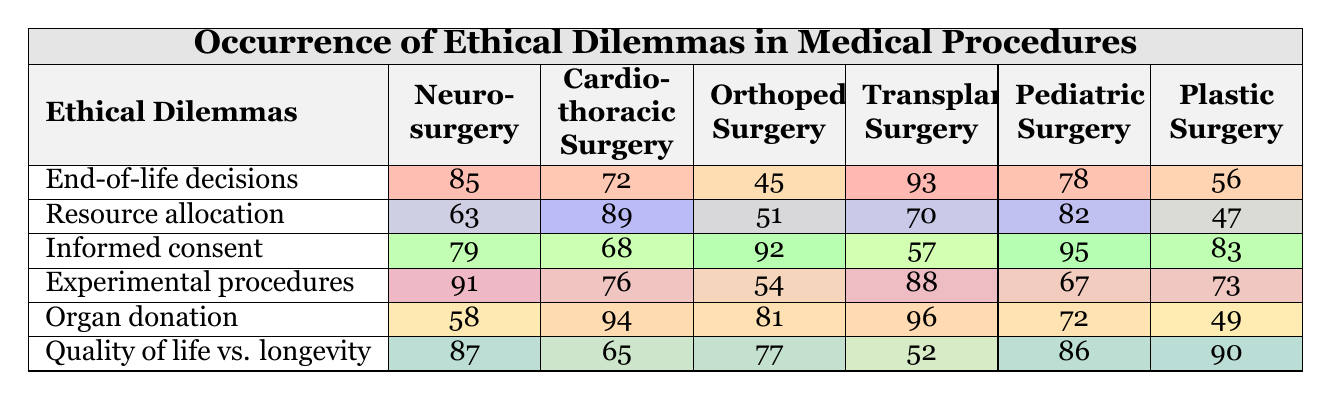What is the occurrence of end-of-life decisions in Pediatric Surgery? In the table, the occurrence of end-of-life decisions in Pediatric Surgery is represented in the corresponding row and column intersection, which shows the value of 78.
Answer: 78 Which surgical specialty has the highest occurrence of resource allocation dilemmas? By examining the column for resource allocation, Cardiothoracic Surgery has the highest occurrence with a value of 89.
Answer: Cardiothoracic Surgery What is the difference in occurrences of informed consent between Orthopedic Surgery and Transplant Surgery? From the informed consent row, the value for Orthopedic Surgery is 92 and for Transplant Surgery, it is 57. The difference is calculated as 92 - 57 = 35.
Answer: 35 What is the average occurrence of ethical dilemmas in Plastic Surgery? The values in the Plastic Surgery column are 56, 47, 83, 73, 49, and 90. Adding these gives 398, and dividing by 6 gives an average of 66.33.
Answer: 66.33 Which ethical dilemma has the lowest occurrence in Orthopedic Surgery? Looking at the Orthopedic Surgery column, the values are 45 (end-of-life decisions), 51 (resource allocation), 92 (informed consent), 54 (experimental procedures), 95 (organ donation), and 77 (quality of life vs. longevity). The lowest value here is 45.
Answer: End-of-life decisions How does the occurrence of organ donation compare between Transplant Surgery and Pediatric Surgery? Checking the values, Transplant Surgery has 96 occurrences of organ donation while Pediatric Surgery has 72. The difference shows that Transplant Surgery has 24 more occurrences than Pediatric Surgery.
Answer: Transplant Surgery has more by 24 Is it true that Experimental procedures have a higher occurrence in Neurosurgery than in Pediatric Surgery? The occurrence of Experimental procedures in Neurosurgery is 91, while in Pediatric Surgery it is 67. Since 91 is greater than 67, the statement is true.
Answer: Yes Which surgical specialty has the least overall occurrences of ethical dilemmas across all categories? By summing the occurrences for each specialty: Neurosurgery (85 + 63 + 79 + 91 + 58 + 87 = 463), Cardiothoracic (72 + 89 + 68 + 76 + 94 + 65 = 464), Orthopedic (45 + 51 + 92 + 54 + 81 + 77 = 400), Transplant (93 + 70 + 57 + 88 + 96 + 52 = 456), Pediatric (78 + 82 + 95 + 67 + 72 + 86 = 480), and Plastic Surgery (56 + 47 + 83 + 73 + 49 + 90 = 398). The least is 398 for Plastic Surgery.
Answer: Plastic Surgery What is the total occurrence of ethical dilemmas for Pediatric Surgery? Adding the occurrences for Pediatric Surgery gives: 78 (end-of-life decisions) + 82 (resource allocation) + 95 (informed consent) + 67 (experimental procedures) + 72 (organ donation) + 86 (quality of life vs. longevity) = 480.
Answer: 480 Which ethical dilemma has the highest combined occurrences across all specialties? To find this, the occurrences for each dilemma must be summed: End-of-life decisions (85 + 63 + 79 + 91 + 58 + 87 = 463), Resource allocation (72 + 89 + 68 + 70 + 82 + 65 = 446), Informed consent (45 + 51 + 92 + 57 + 95 + 83 = 423), Experimental procedures (93 + 76 + 54 + 88 + 96 + 73 = 480), Organ donation (58 + 94 + 81 + 96 + 72 + 49 = 450), Quality of life vs. longevity (87 + 65 + 77 + 52 + 86 + 90 = 457). The highest is 480 for Experimental procedures.
Answer: Experimental procedures 